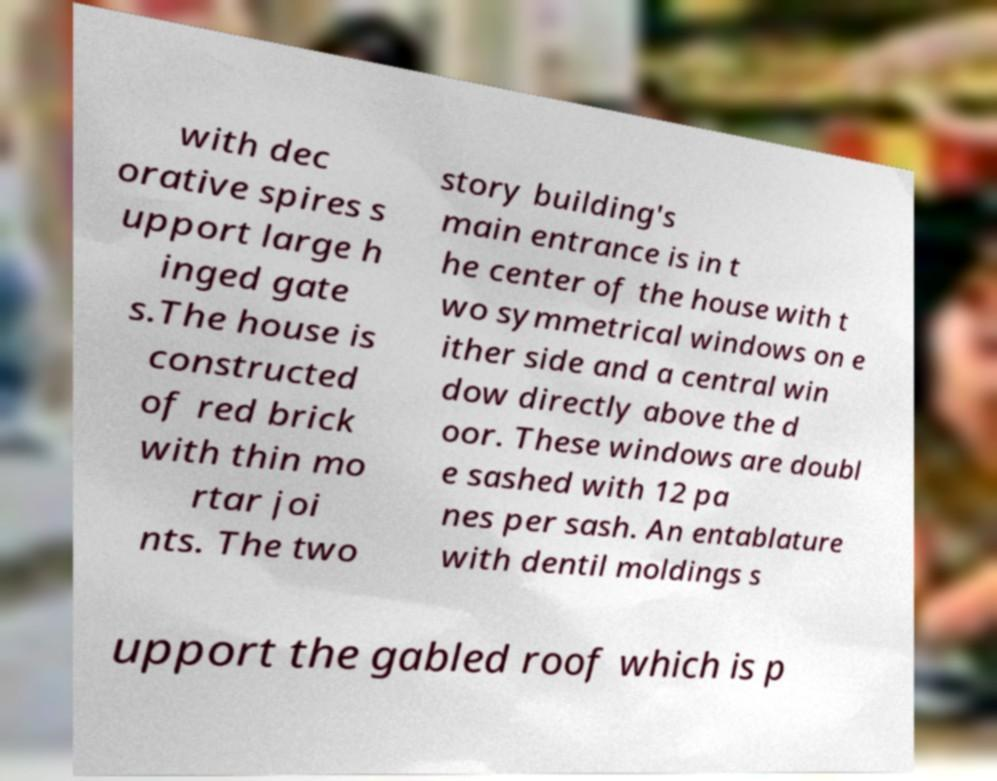Could you assist in decoding the text presented in this image and type it out clearly? with dec orative spires s upport large h inged gate s.The house is constructed of red brick with thin mo rtar joi nts. The two story building's main entrance is in t he center of the house with t wo symmetrical windows on e ither side and a central win dow directly above the d oor. These windows are doubl e sashed with 12 pa nes per sash. An entablature with dentil moldings s upport the gabled roof which is p 